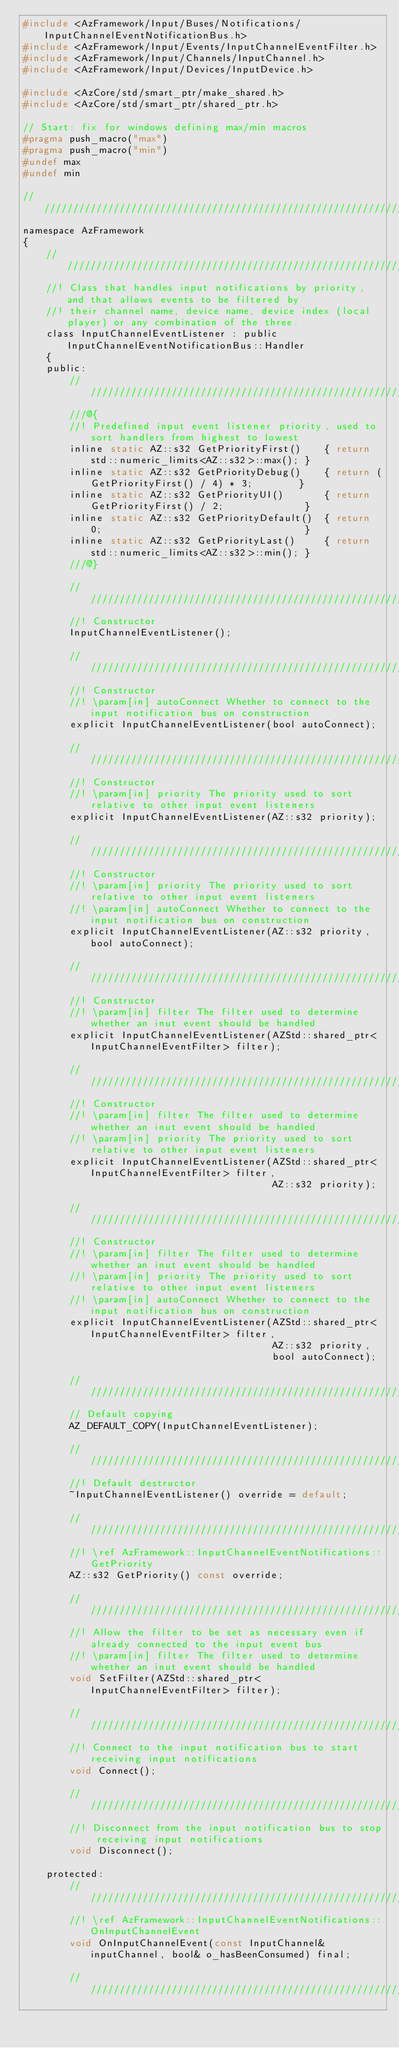Convert code to text. <code><loc_0><loc_0><loc_500><loc_500><_C_>#include <AzFramework/Input/Buses/Notifications/InputChannelEventNotificationBus.h>
#include <AzFramework/Input/Events/InputChannelEventFilter.h>
#include <AzFramework/Input/Channels/InputChannel.h>
#include <AzFramework/Input/Devices/InputDevice.h>

#include <AzCore/std/smart_ptr/make_shared.h>
#include <AzCore/std/smart_ptr/shared_ptr.h>

// Start: fix for windows defining max/min macros
#pragma push_macro("max")
#pragma push_macro("min")
#undef max
#undef min

////////////////////////////////////////////////////////////////////////////////////////////////////
namespace AzFramework
{
    ////////////////////////////////////////////////////////////////////////////////////////////////
    //! Class that handles input notifications by priority, and that allows events to be filtered by
    //! their channel name, device name, device index (local player) or any combination of the three.
    class InputChannelEventListener : public InputChannelEventNotificationBus::Handler
    {
    public:
        ////////////////////////////////////////////////////////////////////////////////////////////
        ///@{
        //! Predefined input event listener priority, used to sort handlers from highest to lowest
        inline static AZ::s32 GetPriorityFirst()    { return std::numeric_limits<AZ::s32>::max(); }
        inline static AZ::s32 GetPriorityDebug()    { return (GetPriorityFirst() / 4) * 3;        }
        inline static AZ::s32 GetPriorityUI()       { return GetPriorityFirst() / 2;              }
        inline static AZ::s32 GetPriorityDefault()  { return 0;                                   }
        inline static AZ::s32 GetPriorityLast()     { return std::numeric_limits<AZ::s32>::min(); }
        ///@}

        ////////////////////////////////////////////////////////////////////////////////////////////
        //! Constructor
        InputChannelEventListener();

        ////////////////////////////////////////////////////////////////////////////////////////////
        //! Constructor
        //! \param[in] autoConnect Whether to connect to the input notification bus on construction
        explicit InputChannelEventListener(bool autoConnect);

        ////////////////////////////////////////////////////////////////////////////////////////////
        //! Constructor
        //! \param[in] priority The priority used to sort relative to other input event listeners
        explicit InputChannelEventListener(AZ::s32 priority);

        ////////////////////////////////////////////////////////////////////////////////////////////
        //! Constructor
        //! \param[in] priority The priority used to sort relative to other input event listeners
        //! \param[in] autoConnect Whether to connect to the input notification bus on construction
        explicit InputChannelEventListener(AZ::s32 priority, bool autoConnect);

        ////////////////////////////////////////////////////////////////////////////////////////////
        //! Constructor
        //! \param[in] filter The filter used to determine whether an inut event should be handled
        explicit InputChannelEventListener(AZStd::shared_ptr<InputChannelEventFilter> filter);

        ////////////////////////////////////////////////////////////////////////////////////////////
        //! Constructor
        //! \param[in] filter The filter used to determine whether an inut event should be handled
        //! \param[in] priority The priority used to sort relative to other input event listeners
        explicit InputChannelEventListener(AZStd::shared_ptr<InputChannelEventFilter> filter,
                                           AZ::s32 priority);

        ////////////////////////////////////////////////////////////////////////////////////////////
        //! Constructor
        //! \param[in] filter The filter used to determine whether an inut event should be handled
        //! \param[in] priority The priority used to sort relative to other input event listeners
        //! \param[in] autoConnect Whether to connect to the input notification bus on construction
        explicit InputChannelEventListener(AZStd::shared_ptr<InputChannelEventFilter> filter,
                                           AZ::s32 priority,
                                           bool autoConnect);

        ////////////////////////////////////////////////////////////////////////////////////////////
        // Default copying
        AZ_DEFAULT_COPY(InputChannelEventListener);

        ////////////////////////////////////////////////////////////////////////////////////////////
        //! Default destructor
        ~InputChannelEventListener() override = default;

        ////////////////////////////////////////////////////////////////////////////////////////////
        //! \ref AzFramework::InputChannelEventNotifications::GetPriority
        AZ::s32 GetPriority() const override;

        ////////////////////////////////////////////////////////////////////////////////////////////
        //! Allow the filter to be set as necessary even if already connected to the input event bus
        //! \param[in] filter The filter used to determine whether an inut event should be handled
        void SetFilter(AZStd::shared_ptr<InputChannelEventFilter> filter);

        ////////////////////////////////////////////////////////////////////////////////////////////
        //! Connect to the input notification bus to start receiving input notifications
        void Connect();

        ////////////////////////////////////////////////////////////////////////////////////////////
        //! Disconnect from the input notification bus to stop receiving input notifications
        void Disconnect();

    protected:
        ////////////////////////////////////////////////////////////////////////////////////////////
        //! \ref AzFramework::InputChannelEventNotifications::OnInputChannelEvent
        void OnInputChannelEvent(const InputChannel& inputChannel, bool& o_hasBeenConsumed) final;

        ////////////////////////////////////////////////////////////////////////////////////////////</code> 